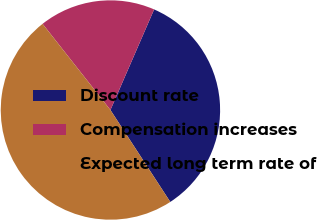<chart> <loc_0><loc_0><loc_500><loc_500><pie_chart><fcel>Discount rate<fcel>Compensation increases<fcel>Expected long term rate of<nl><fcel>34.29%<fcel>17.14%<fcel>48.57%<nl></chart> 